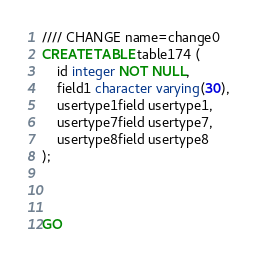Convert code to text. <code><loc_0><loc_0><loc_500><loc_500><_SQL_>//// CHANGE name=change0
CREATE TABLE table174 (
    id integer NOT NULL,
    field1 character varying(30),
    usertype1field usertype1,
    usertype7field usertype7,
    usertype8field usertype8
);



GO
</code> 